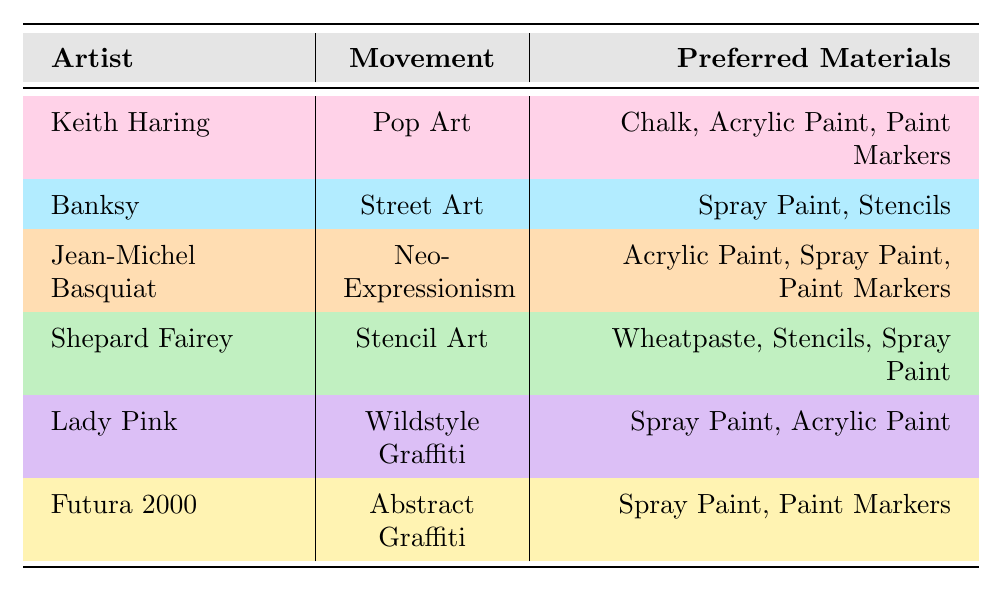What preferred materials does Jean-Michel Basquiat use? According to the table, Jean-Michel Basquiat’s preferred materials are listed as Acrylic Paint, Spray Paint, and Paint Markers.
Answer: Acrylic Paint, Spray Paint, Paint Markers Which artist prefers Wheatpaste as a material? The table indicates that only Shepard Fairey prefers Wheatpaste as one of his materials.
Answer: Shepard Fairey How many artists use Spray Paint as a preferred material? The table shows that Banksy, Jean-Michel Basquiat, Lady Pink, Shepard Fairey, and Futura 2000 all use Spray Paint. This sums up to a total of 5 artists.
Answer: 5 Is Stencils a preferred material for Keith Haring? The table states that Keith Haring’s preferred materials are Chalk, Acrylic Paint, and Paint Markers; hence, Stencils is not one of them.
Answer: No Which art movement is associated with the use of Paint Markers by multiple artists? Both Keith Haring and Jean-Michel Basquiat in their respective movements, Pop Art and Neo-Expressionism, use Paint Markers. Therefore, Paint Markers are associated with these movements.
Answer: Pop Art, Neo-Expressionism What is the unique material used by Shepard Fairey that is not used by any other artist listed? The table reveals that Wheatpaste is exclusively used by Shepard Fairey and not mentioned by any other artists, making it a unique material for him.
Answer: Wheatpaste How many different movements are represented by artists who prefer Spray Paint? From the table, the movements represented by artists who use Spray Paint include Street Art (Banksy), Neo-Expressionism (Jean-Michel Basquiat), Wildstyle Graffiti (Lady Pink), Stencil Art (Shepard Fairey), and Abstract Graffiti (Futura 2000). This totals to 5 different movements.
Answer: 5 Do any two artists share the same set of preferred materials? Analyzing the table shows that no two artists have the exact combination of preferred materials listed; each has a distinct set.
Answer: No Which movement has the most preferred materials listed by its associated artist(s)? Looking closely, both Jean-Michel Basquiat and Shepard Fairey have 3 preferred materials each. Hence, Neo-Expressionism and Stencil Art have the most preferred materials associated with them.
Answer: Neo-Expressionism, Stencil Art Is it true that all artists listed use either Spray Paint or Acrylic Paint? The table confirms that while most artists do use either Spray Paint or Acrylic Paint, Keith Haring does not use Spray Paint at all. Therefore, the statement is false.
Answer: False 